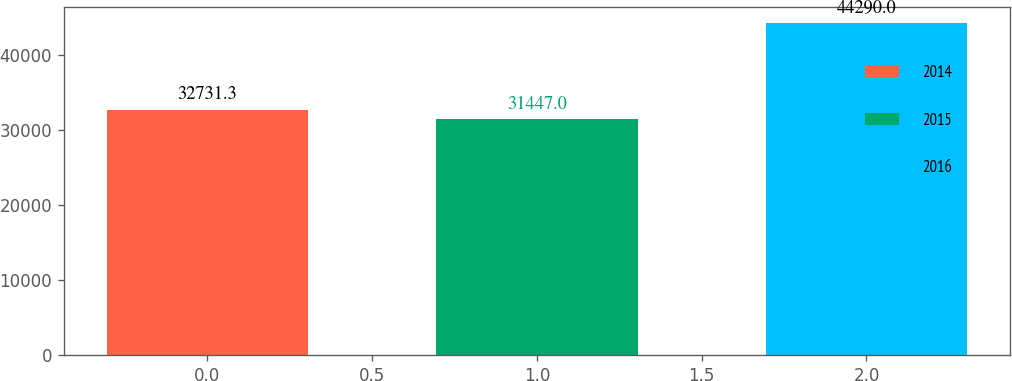<chart> <loc_0><loc_0><loc_500><loc_500><bar_chart><fcel>2014<fcel>2015<fcel>2016<nl><fcel>32731.3<fcel>31447<fcel>44290<nl></chart> 